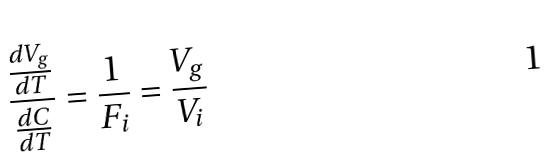<formula> <loc_0><loc_0><loc_500><loc_500>\frac { \frac { d V _ { g } } { d T } } { \frac { d C } { d T } } = \frac { 1 } { F _ { i } } = \frac { V _ { g } } { V _ { i } }</formula> 